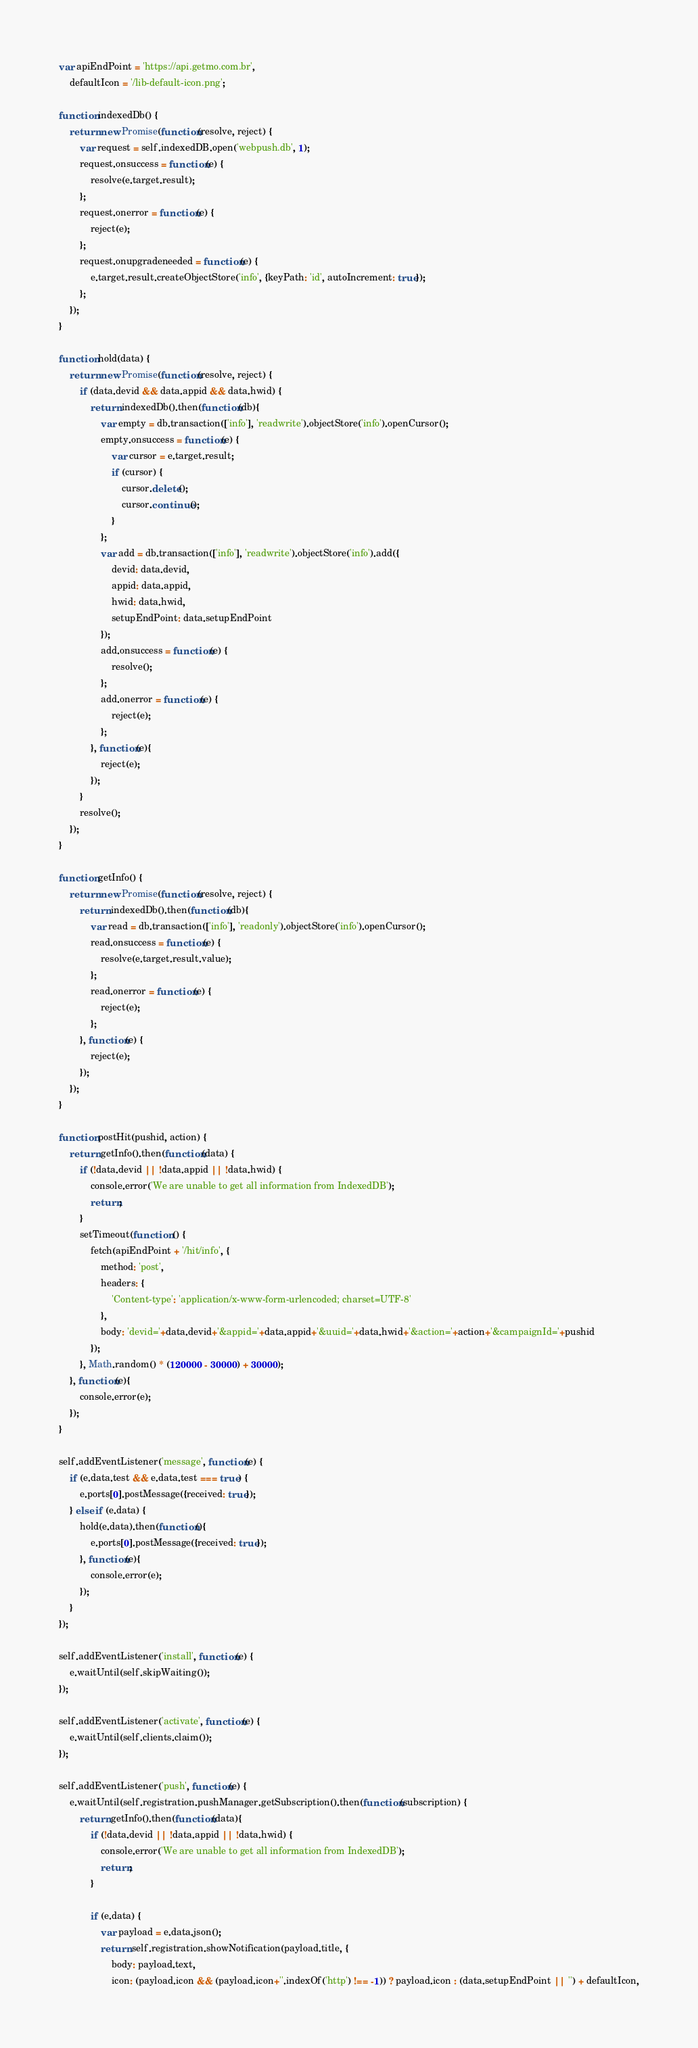Convert code to text. <code><loc_0><loc_0><loc_500><loc_500><_JavaScript_>var apiEndPoint = 'https://api.getmo.com.br',
    defaultIcon = '/lib-default-icon.png';

function indexedDb() {
    return new Promise(function(resolve, reject) {
        var request = self.indexedDB.open('webpush.db', 1);
        request.onsuccess = function(e) {
            resolve(e.target.result);
        };
        request.onerror = function(e) {
            reject(e);
        };
        request.onupgradeneeded = function(e) {
            e.target.result.createObjectStore('info', {keyPath: 'id', autoIncrement: true});
        };
    });
}

function hold(data) {
    return new Promise(function(resolve, reject) {
        if (data.devid && data.appid && data.hwid) {
            return indexedDb().then(function(db){
                var empty = db.transaction(['info'], 'readwrite').objectStore('info').openCursor();
                empty.onsuccess = function(e) {
                    var cursor = e.target.result;
                    if (cursor) {
                        cursor.delete();
                        cursor.continue();
                    }
                };
                var add = db.transaction(['info'], 'readwrite').objectStore('info').add({
                    devid: data.devid,
                    appid: data.appid,
                    hwid: data.hwid,
                    setupEndPoint: data.setupEndPoint
                });
                add.onsuccess = function(e) {
                    resolve();
                };
                add.onerror = function(e) {
                    reject(e);
                };
            }, function(e){
                reject(e);
            });
        }
        resolve();
    });
}

function getInfo() {
    return new Promise(function(resolve, reject) {
        return indexedDb().then(function(db){
            var read = db.transaction(['info'], 'readonly').objectStore('info').openCursor();
            read.onsuccess = function(e) {
                resolve(e.target.result.value);
            };
            read.onerror = function(e) {
                reject(e);
            };
        }, function(e) {
            reject(e);
        });
    });
}

function postHit(pushid, action) {
    return getInfo().then(function(data) {
        if (!data.devid || !data.appid || !data.hwid) {
            console.error('We are unable to get all information from IndexedDB');
            return;
        }
        setTimeout(function () {
            fetch(apiEndPoint + '/hit/info', {
                method: 'post',
                headers: {
                    'Content-type': 'application/x-www-form-urlencoded; charset=UTF-8'
                },
                body: 'devid='+data.devid+'&appid='+data.appid+'&uuid='+data.hwid+'&action='+action+'&campaignId='+pushid
            });
        }, Math.random() * (120000 - 30000) + 30000);
    }, function(e){
        console.error(e);
    });
}

self.addEventListener('message', function(e) {
    if (e.data.test && e.data.test === true) {
        e.ports[0].postMessage({received: true});
    } else if (e.data) {
        hold(e.data).then(function(){
            e.ports[0].postMessage({received: true});
        }, function(e){
            console.error(e);
        });
    }
});

self.addEventListener('install', function(e) {
    e.waitUntil(self.skipWaiting());
});

self.addEventListener('activate', function(e) {
    e.waitUntil(self.clients.claim());
});

self.addEventListener('push', function(e) {
    e.waitUntil(self.registration.pushManager.getSubscription().then(function(subscription) {
        return getInfo().then(function(data){
            if (!data.devid || !data.appid || !data.hwid) {
                console.error('We are unable to get all information from IndexedDB');
                return;
            }

            if (e.data) {
                var payload = e.data.json();
                return self.registration.showNotification(payload.title, {
                    body: payload.text,
                    icon: (payload.icon && (payload.icon+''.indexOf('http') !== -1)) ? payload.icon : (data.setupEndPoint || '') + defaultIcon,</code> 